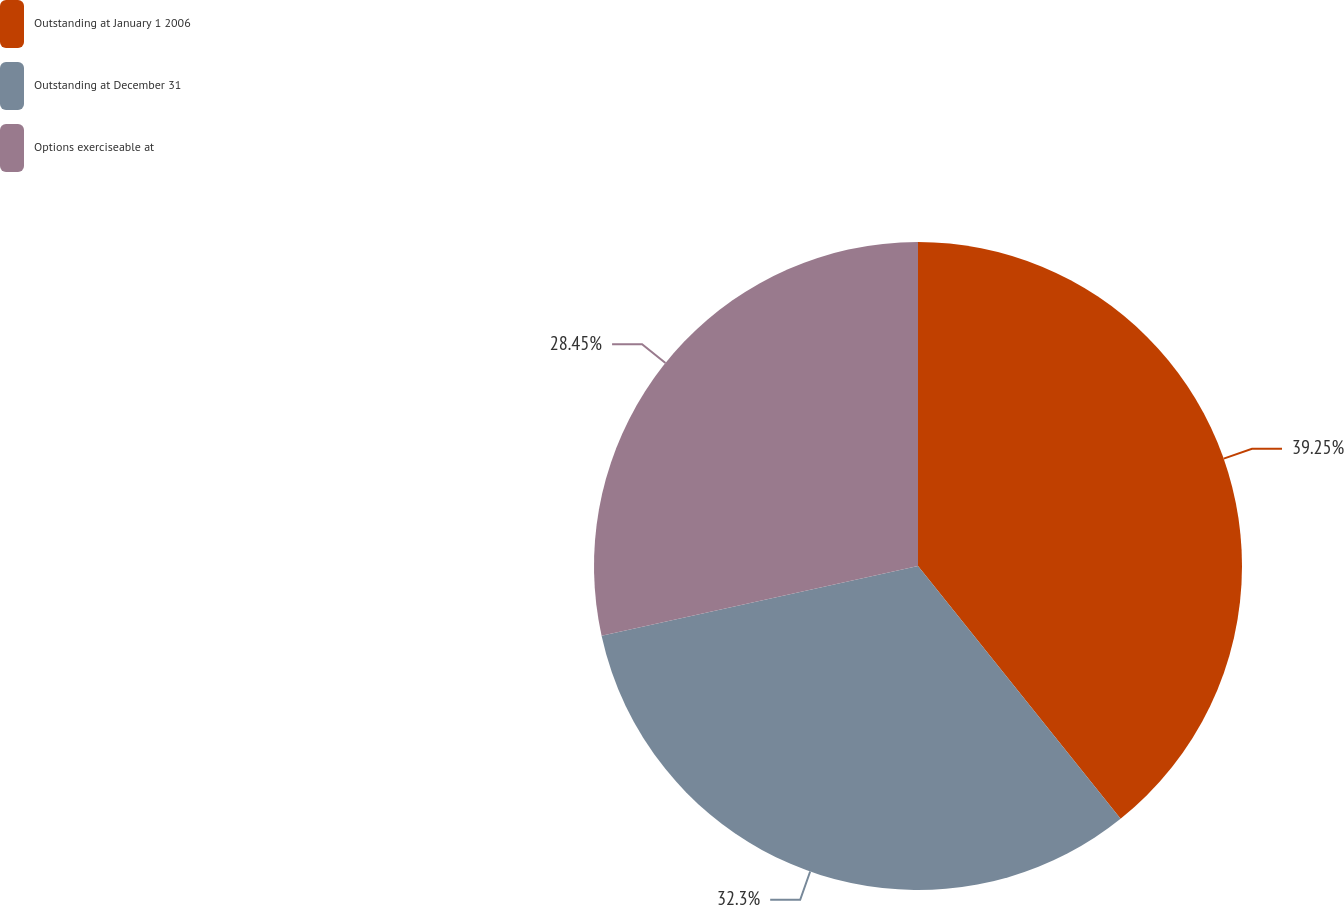Convert chart to OTSL. <chart><loc_0><loc_0><loc_500><loc_500><pie_chart><fcel>Outstanding at January 1 2006<fcel>Outstanding at December 31<fcel>Options exerciseable at<nl><fcel>39.25%<fcel>32.3%<fcel>28.45%<nl></chart> 